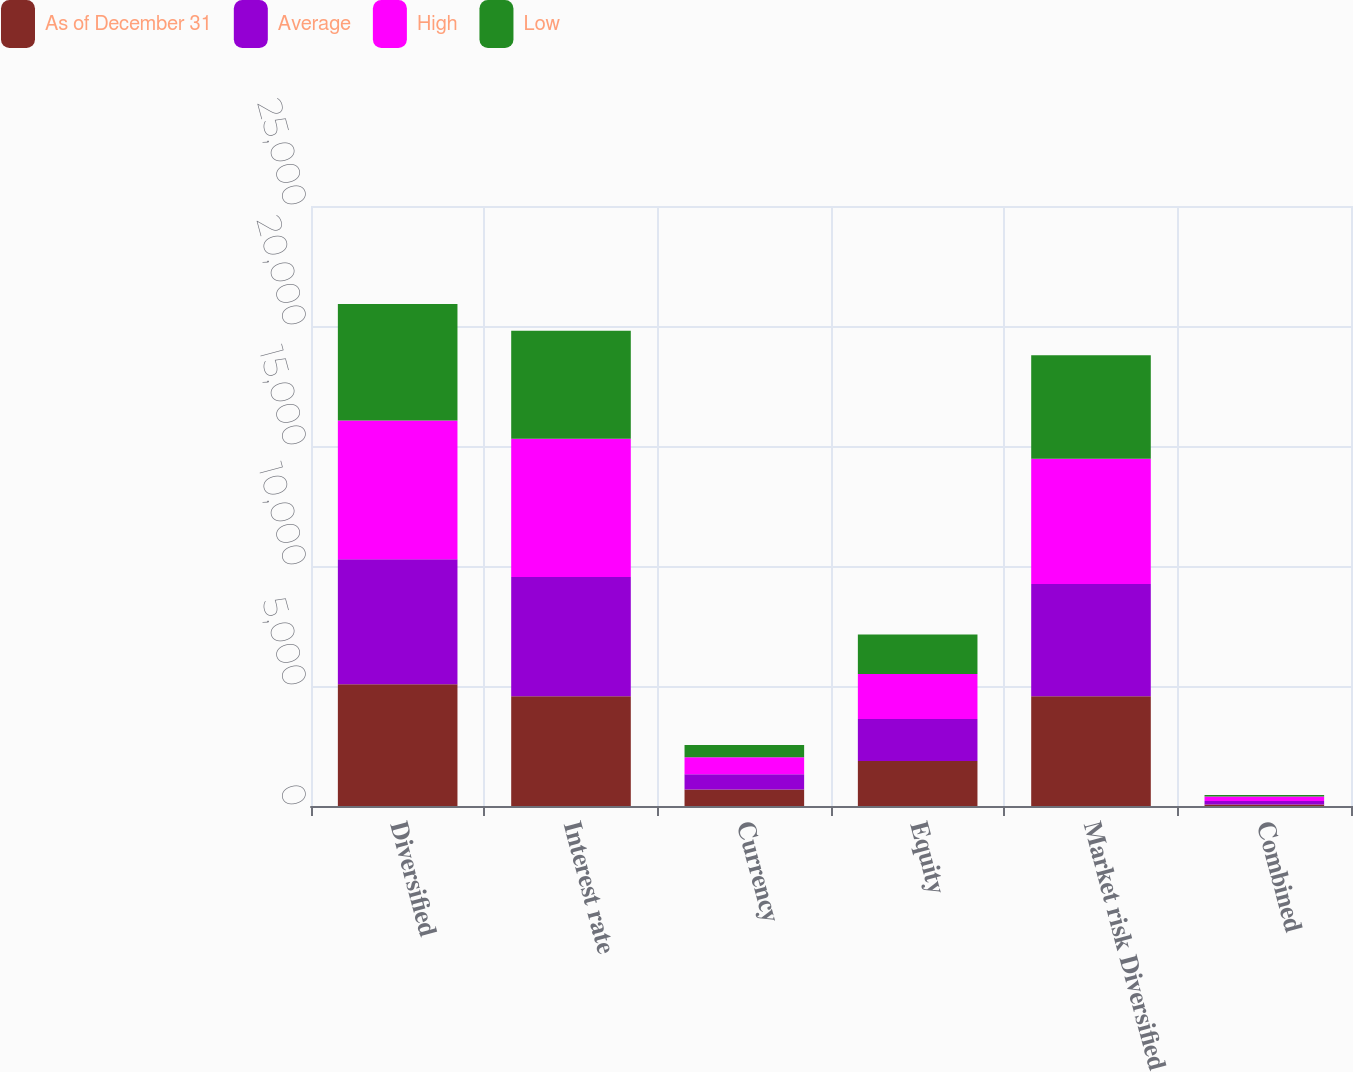Convert chart. <chart><loc_0><loc_0><loc_500><loc_500><stacked_bar_chart><ecel><fcel>Diversified<fcel>Interest rate<fcel>Currency<fcel>Equity<fcel>Market risk Diversified<fcel>Combined<nl><fcel>As of December 31<fcel>5073<fcel>4577<fcel>686<fcel>1873<fcel>4574<fcel>64<nl><fcel>Average<fcel>5209<fcel>4962<fcel>641<fcel>1754<fcel>4672<fcel>144<nl><fcel>High<fcel>5783<fcel>5765<fcel>707<fcel>1873<fcel>5224<fcel>190<nl><fcel>Low<fcel>4852<fcel>4498<fcel>509<fcel>1650<fcel>4307<fcel>64<nl></chart> 